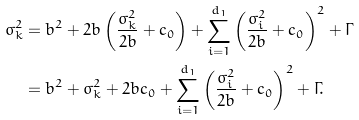<formula> <loc_0><loc_0><loc_500><loc_500>\sigma _ { k } ^ { 2 } & = b ^ { 2 } + 2 b \left ( \frac { \sigma _ { k } ^ { 2 } } { 2 b } + c _ { 0 } \right ) + \sum _ { i = 1 } ^ { d _ { 1 } } \left ( \frac { \sigma _ { i } ^ { 2 } } { 2 b } + c _ { 0 } \right ) ^ { 2 } + \Gamma \\ & = b ^ { 2 } + \sigma _ { k } ^ { 2 } + 2 b c _ { 0 } + \sum _ { i = 1 } ^ { d _ { 1 } } \left ( \frac { \sigma _ { i } ^ { 2 } } { 2 b } + c _ { 0 } \right ) ^ { 2 } + \Gamma .</formula> 